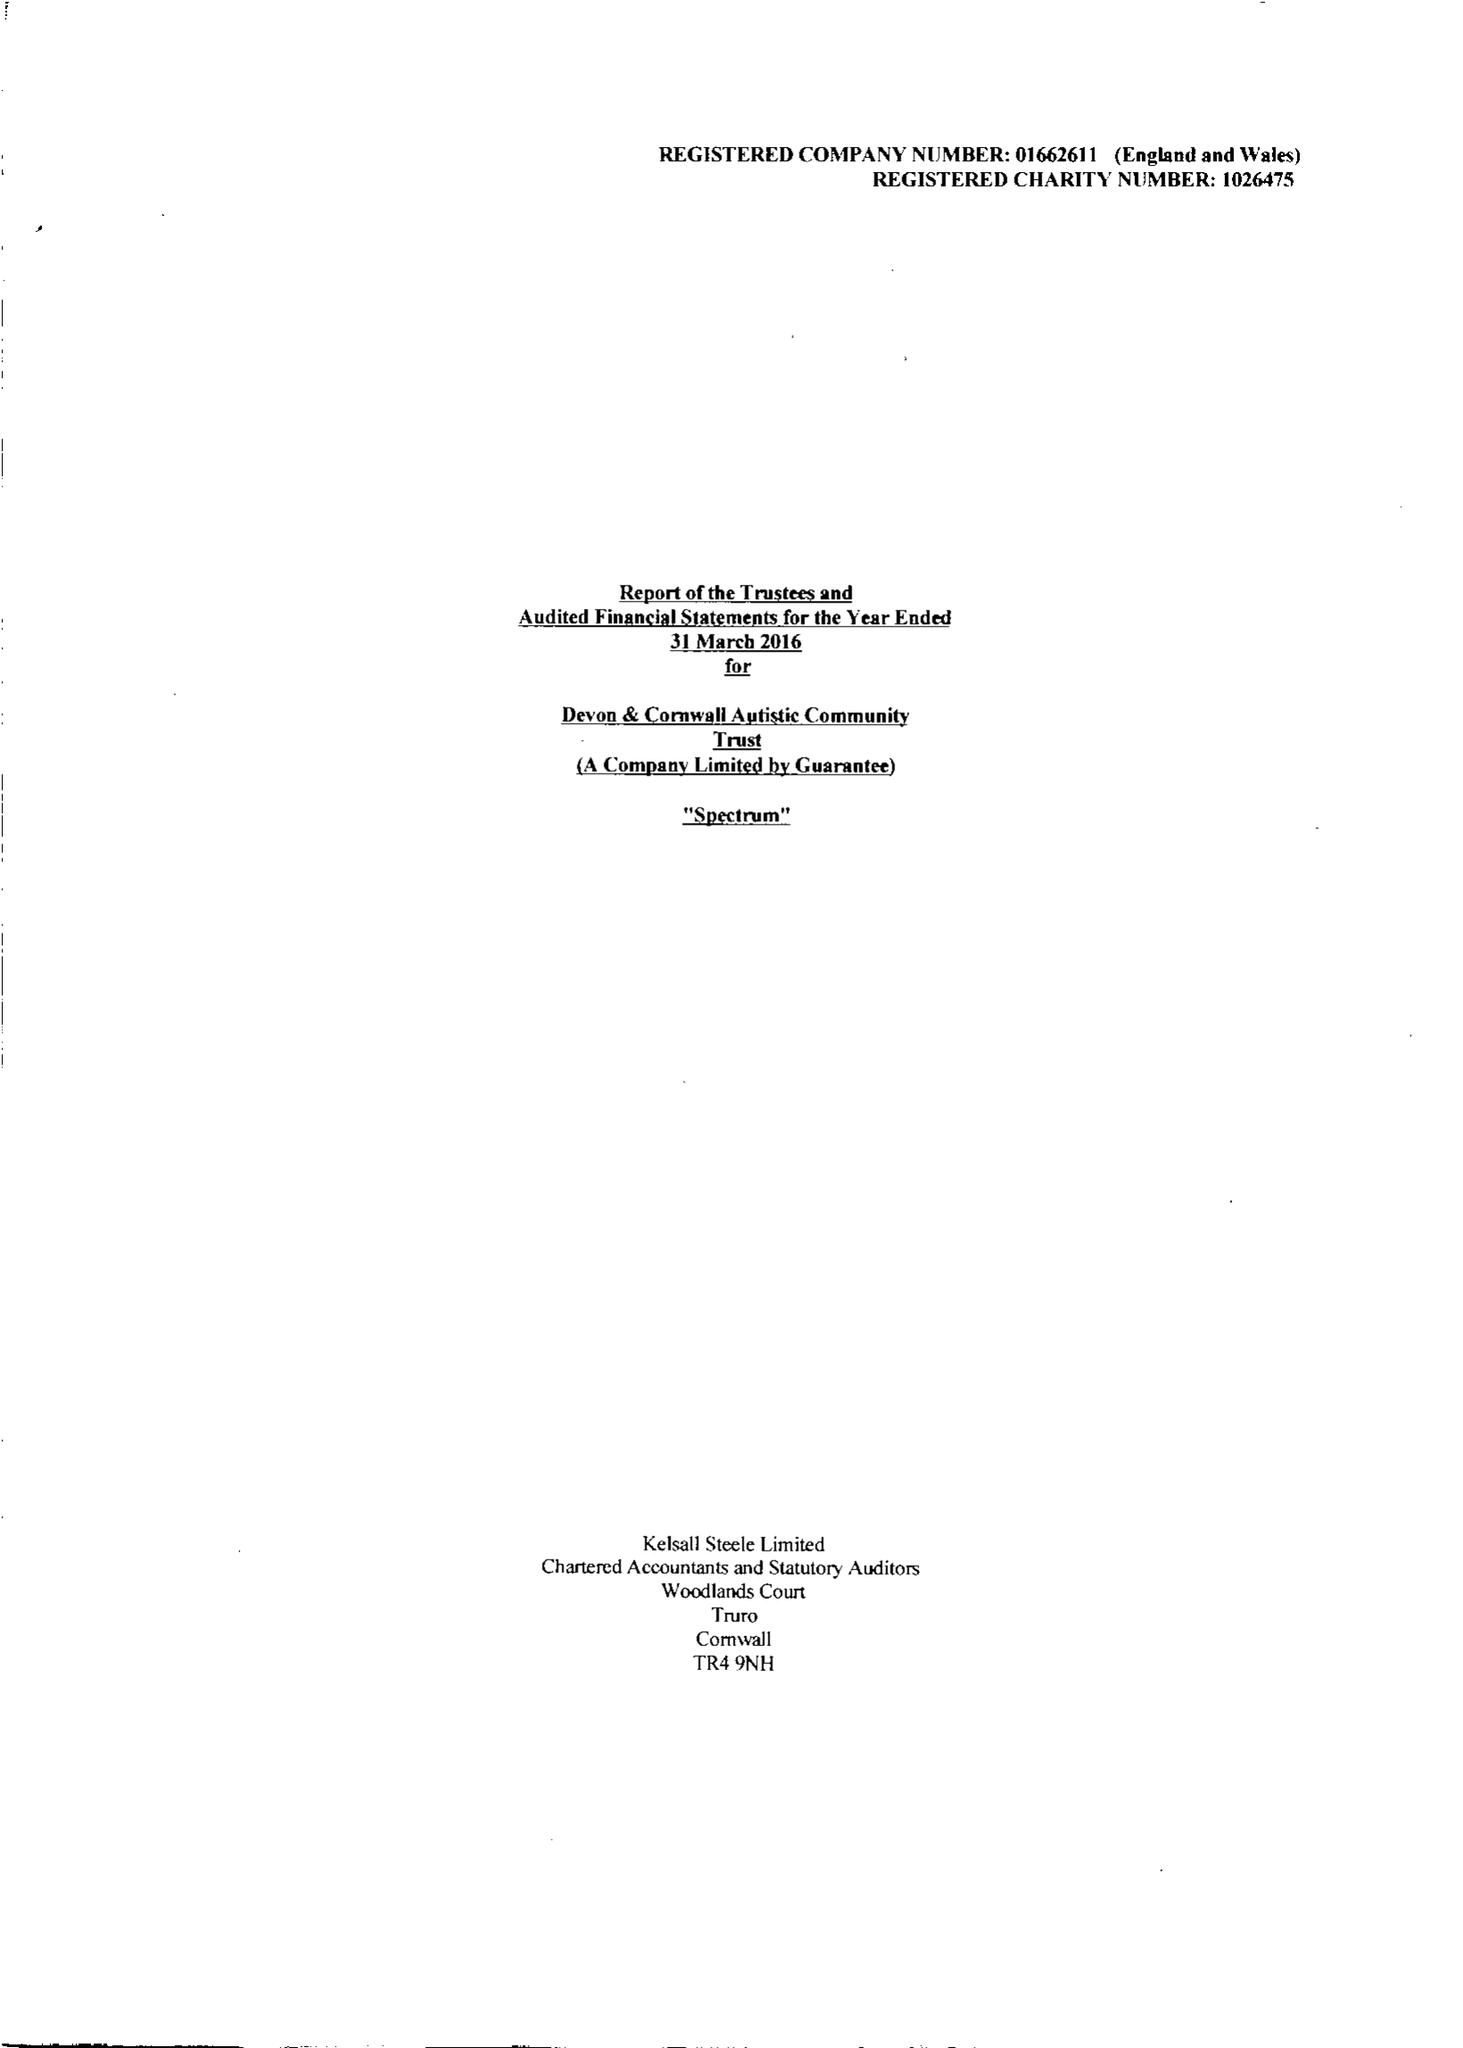What is the value for the report_date?
Answer the question using a single word or phrase. 2016-03-31 